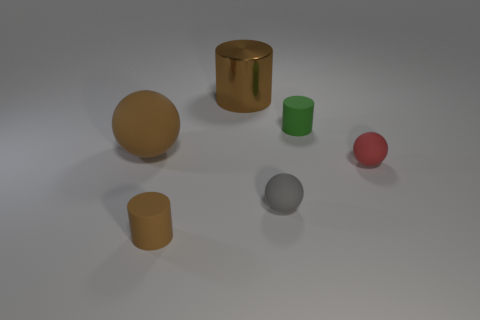Are there fewer matte cylinders than big green shiny balls?
Your answer should be compact. No. What is the material of the brown thing that is the same size as the brown rubber sphere?
Make the answer very short. Metal. Is the number of red matte balls greater than the number of matte cylinders?
Ensure brevity in your answer.  No. What number of other things are the same color as the big rubber ball?
Make the answer very short. 2. What number of matte objects are both behind the red rubber ball and in front of the small red rubber ball?
Your response must be concise. 0. Is the number of large brown matte objects to the left of the large matte object greater than the number of cylinders on the left side of the small brown matte thing?
Ensure brevity in your answer.  No. What is the material of the tiny cylinder that is left of the green rubber thing?
Provide a short and direct response. Rubber. Does the green object have the same shape as the large brown object on the right side of the tiny brown cylinder?
Keep it short and to the point. Yes. How many small gray matte things are in front of the ball that is to the right of the small matte cylinder that is to the right of the brown matte cylinder?
Keep it short and to the point. 1. What is the color of the other small thing that is the same shape as the small red rubber object?
Ensure brevity in your answer.  Gray. 